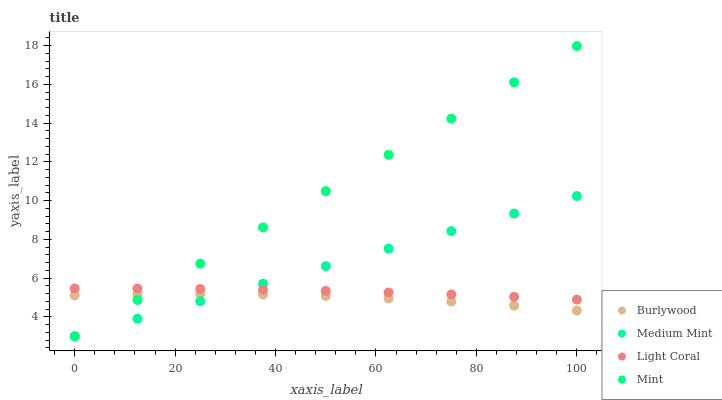Does Burlywood have the minimum area under the curve?
Answer yes or no. Yes. Does Mint have the maximum area under the curve?
Answer yes or no. Yes. Does Medium Mint have the minimum area under the curve?
Answer yes or no. No. Does Medium Mint have the maximum area under the curve?
Answer yes or no. No. Is Medium Mint the smoothest?
Answer yes or no. Yes. Is Burlywood the roughest?
Answer yes or no. Yes. Is Mint the smoothest?
Answer yes or no. No. Is Mint the roughest?
Answer yes or no. No. Does Medium Mint have the lowest value?
Answer yes or no. Yes. Does Light Coral have the lowest value?
Answer yes or no. No. Does Mint have the highest value?
Answer yes or no. Yes. Does Medium Mint have the highest value?
Answer yes or no. No. Is Burlywood less than Light Coral?
Answer yes or no. Yes. Is Light Coral greater than Burlywood?
Answer yes or no. Yes. Does Mint intersect Burlywood?
Answer yes or no. Yes. Is Mint less than Burlywood?
Answer yes or no. No. Is Mint greater than Burlywood?
Answer yes or no. No. Does Burlywood intersect Light Coral?
Answer yes or no. No. 